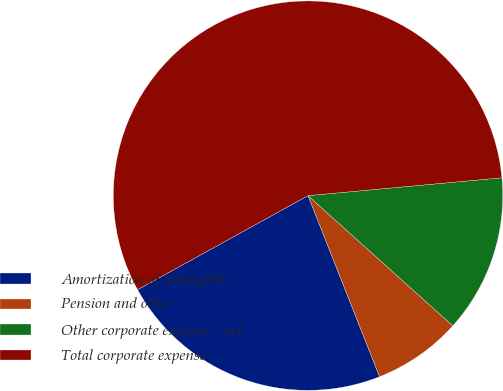Convert chart. <chart><loc_0><loc_0><loc_500><loc_500><pie_chart><fcel>Amortization of intangible<fcel>Pension and other<fcel>Other corporate expense - net<fcel>Total corporate expense<nl><fcel>22.96%<fcel>7.35%<fcel>13.12%<fcel>56.56%<nl></chart> 